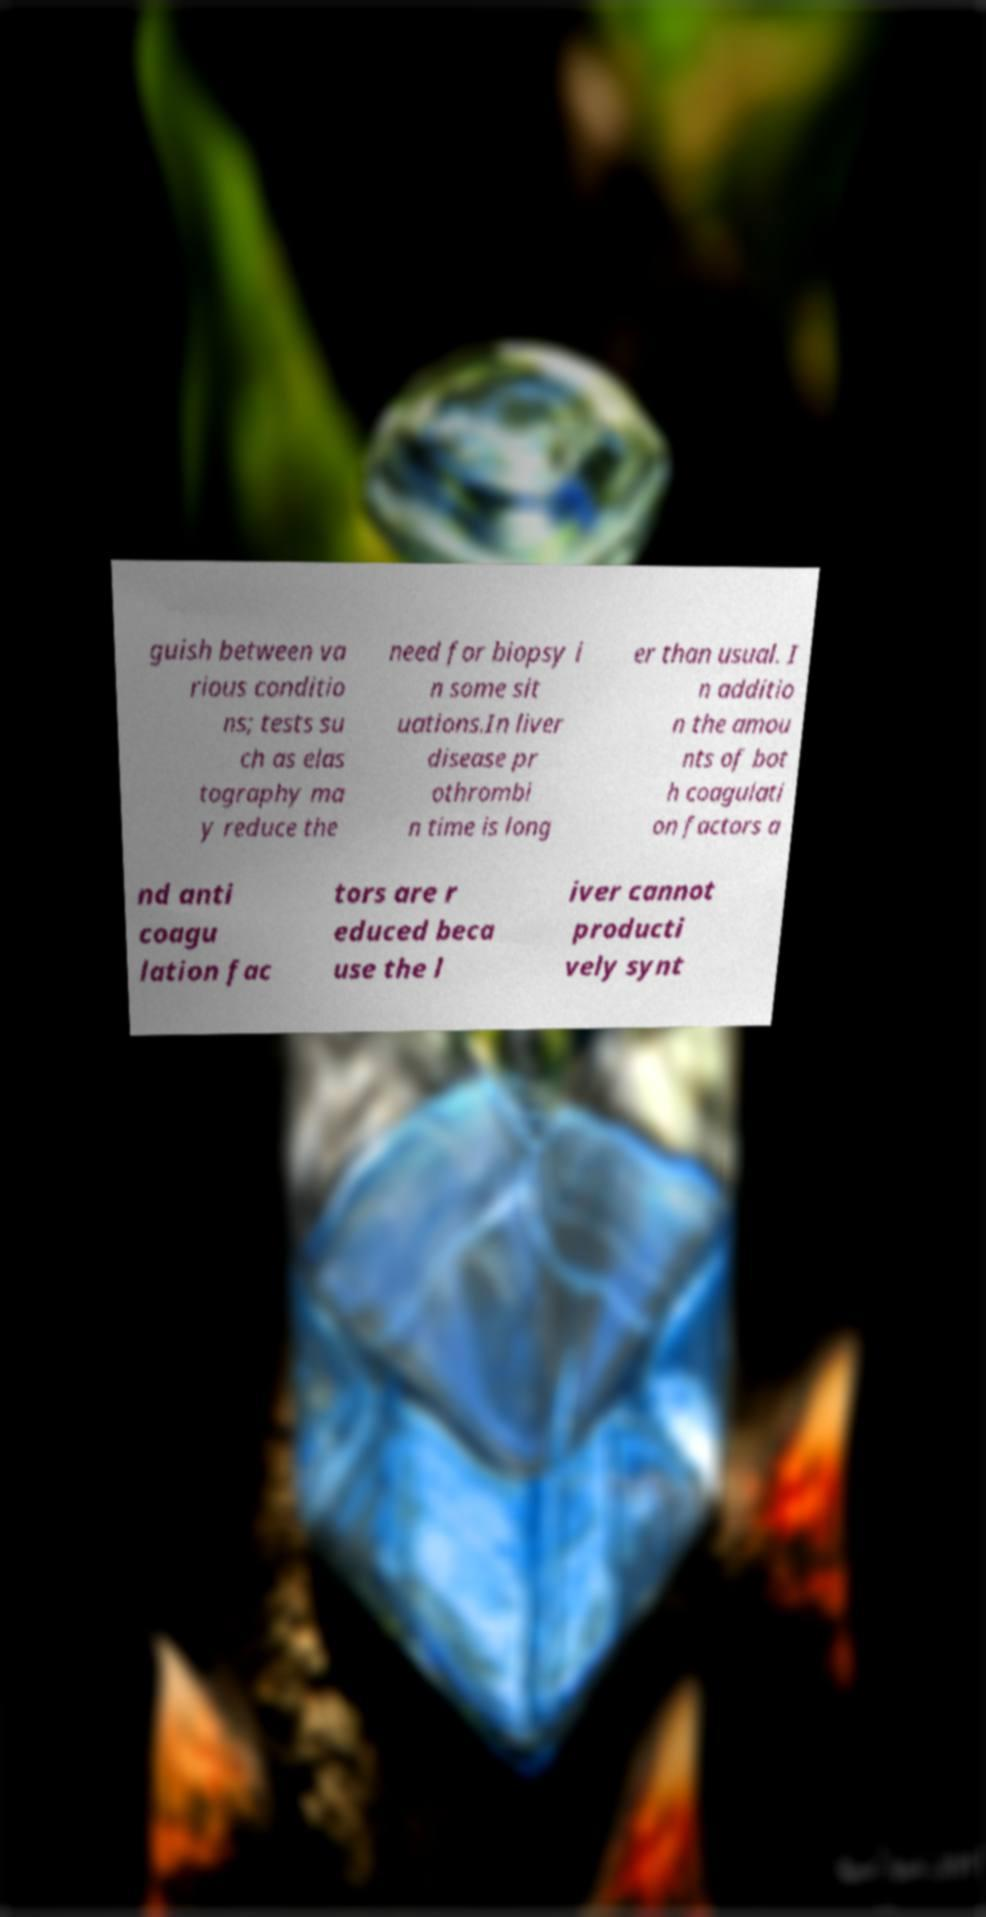Could you extract and type out the text from this image? guish between va rious conditio ns; tests su ch as elas tography ma y reduce the need for biopsy i n some sit uations.In liver disease pr othrombi n time is long er than usual. I n additio n the amou nts of bot h coagulati on factors a nd anti coagu lation fac tors are r educed beca use the l iver cannot producti vely synt 